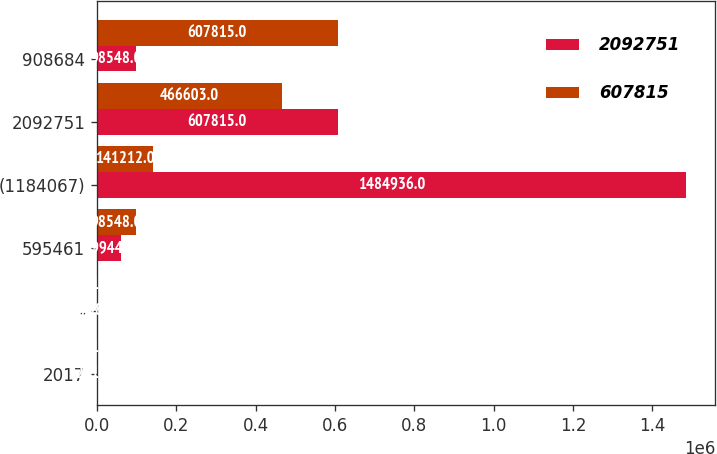Convert chart to OTSL. <chart><loc_0><loc_0><loc_500><loc_500><stacked_bar_chart><ecel><fcel>2017<fcel>-<fcel>595461<fcel>(1184067)<fcel>2092751<fcel>908684<nl><fcel>2.09275e+06<fcel>2016<fcel>758<fcel>59944<fcel>1.48494e+06<fcel>607815<fcel>98548<nl><fcel>607815<fcel>2015<fcel>1216<fcel>98548<fcel>141212<fcel>466603<fcel>607815<nl></chart> 